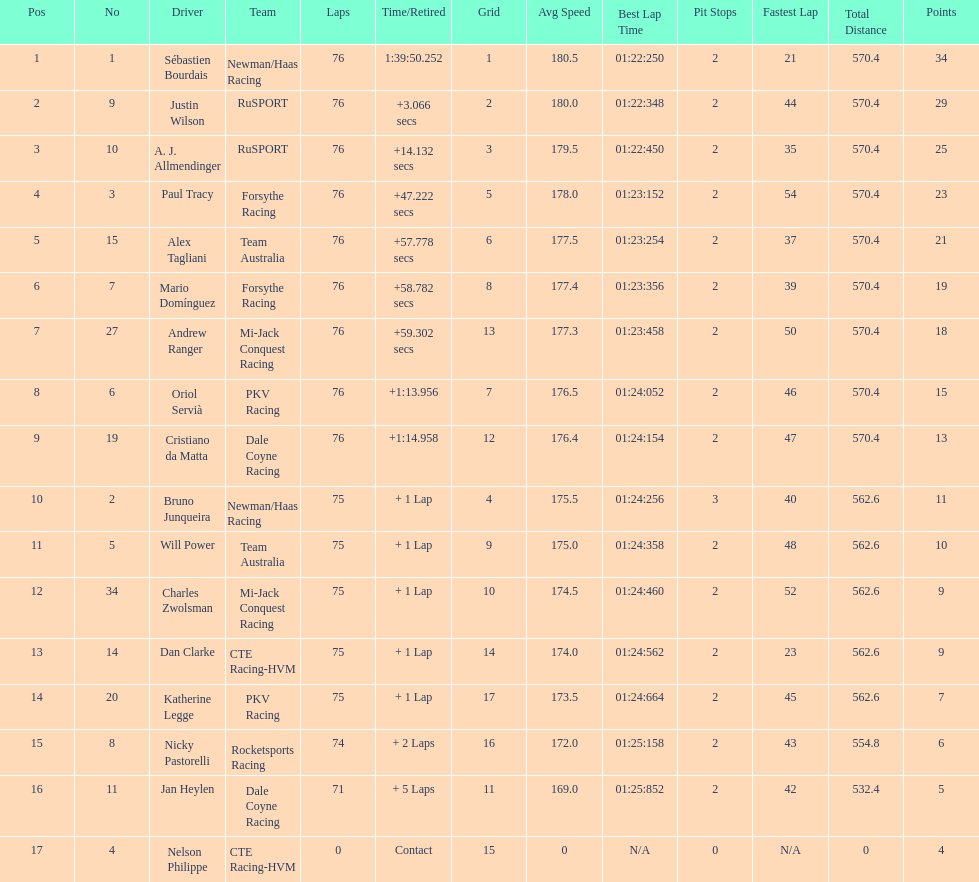What was the total points that canada earned together? 62. 